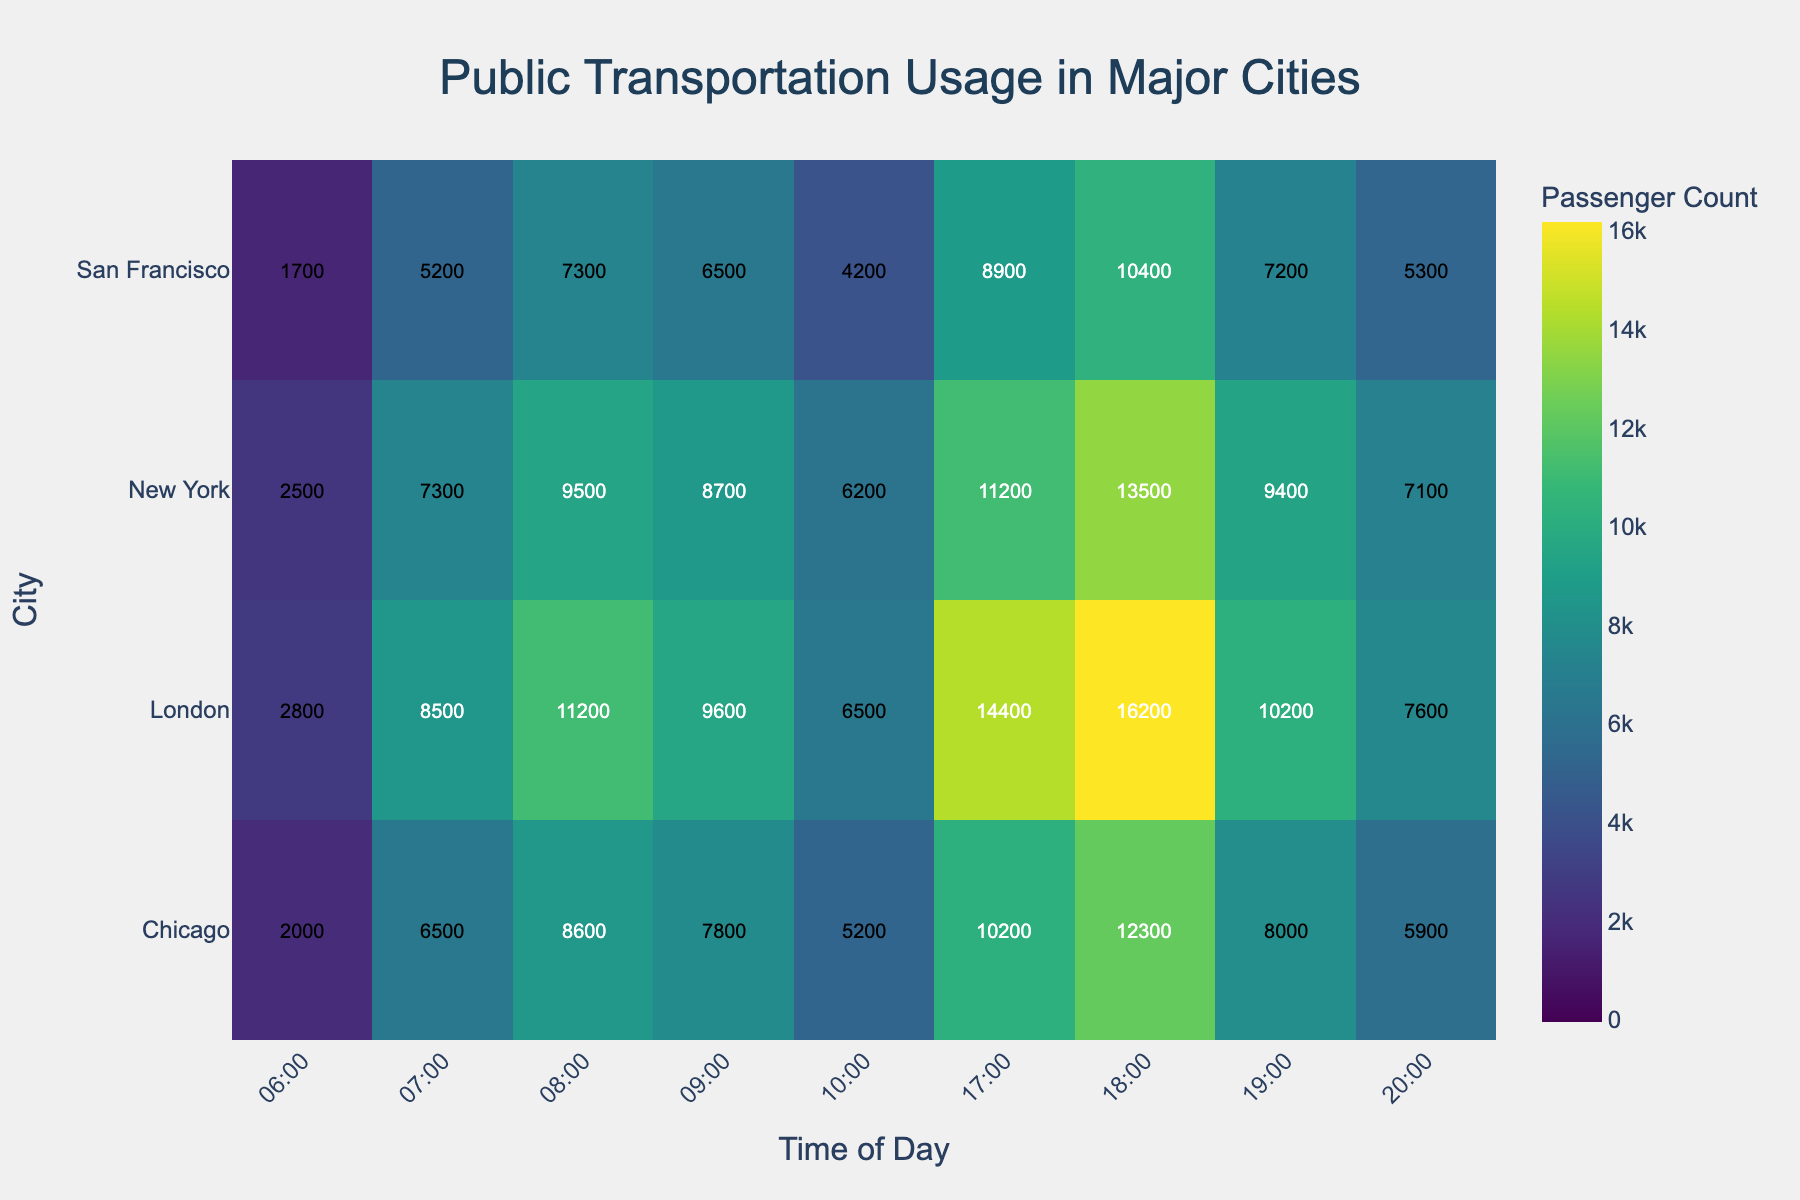What is the title of the heatmap? The title of the heatmap is prominently displayed at the top of the figure, which is a common design practice for clear understanding.
Answer: Public Transportation Usage in Major Cities Which city has the highest transportation usage at 8 AM? By looking at the color intensity at the 8 AM column for each city, the brightest point indicates the highest usage, which is in London.
Answer: London How many cities are represented in the heatmap? Count the number of unique city names on the y-axis to determine the total number of cities represented.
Answer: 4 Which time period in New York has the lowest transportation usage? By locating New York on the y-axis and scanning across the time periods, the lightest color corresponds to the lowest value.
Answer: 6 AM What time shows the peak transportation usage in San Francisco? By following the row for San Francisco, find the cell with the most intense color, which corresponds to the peak usage time.
Answer: 6 PM What is the total passenger count for Chicago at 6 AM and 7 AM combined? Locate the values for Chicago at 6 AM and 7 AM in the heatmap and add them together: 2000 + 6500.
Answer: 8500 Which city has the most consistent transportation usage throughout the displayed day? Compare the intensity of colors across all time periods for each city; the city with the least variation in color intensity is the most consistent.
Answer: San Francisco Between London and New York, which city has a higher passenger count at 5 PM? Locate London and New York rows at the 5 PM column, and compare the values to see which is higher.
Answer: London Compare the passenger counts at 10 AM between all cities and find the city with the highest count. Locate the 10 AM column and compare the values; the highest value will be the darkest color among the cities.
Answer: New York How does the passenger count at 7 PM in Chicago compare to San Francisco? Locate the 7 PM time slot for both Chicago and San Francisco and compare the counts recorded.
Answer: Chicago has a higher count than San Francisco 